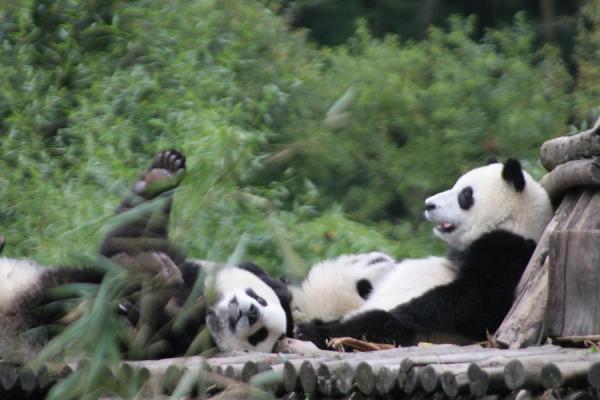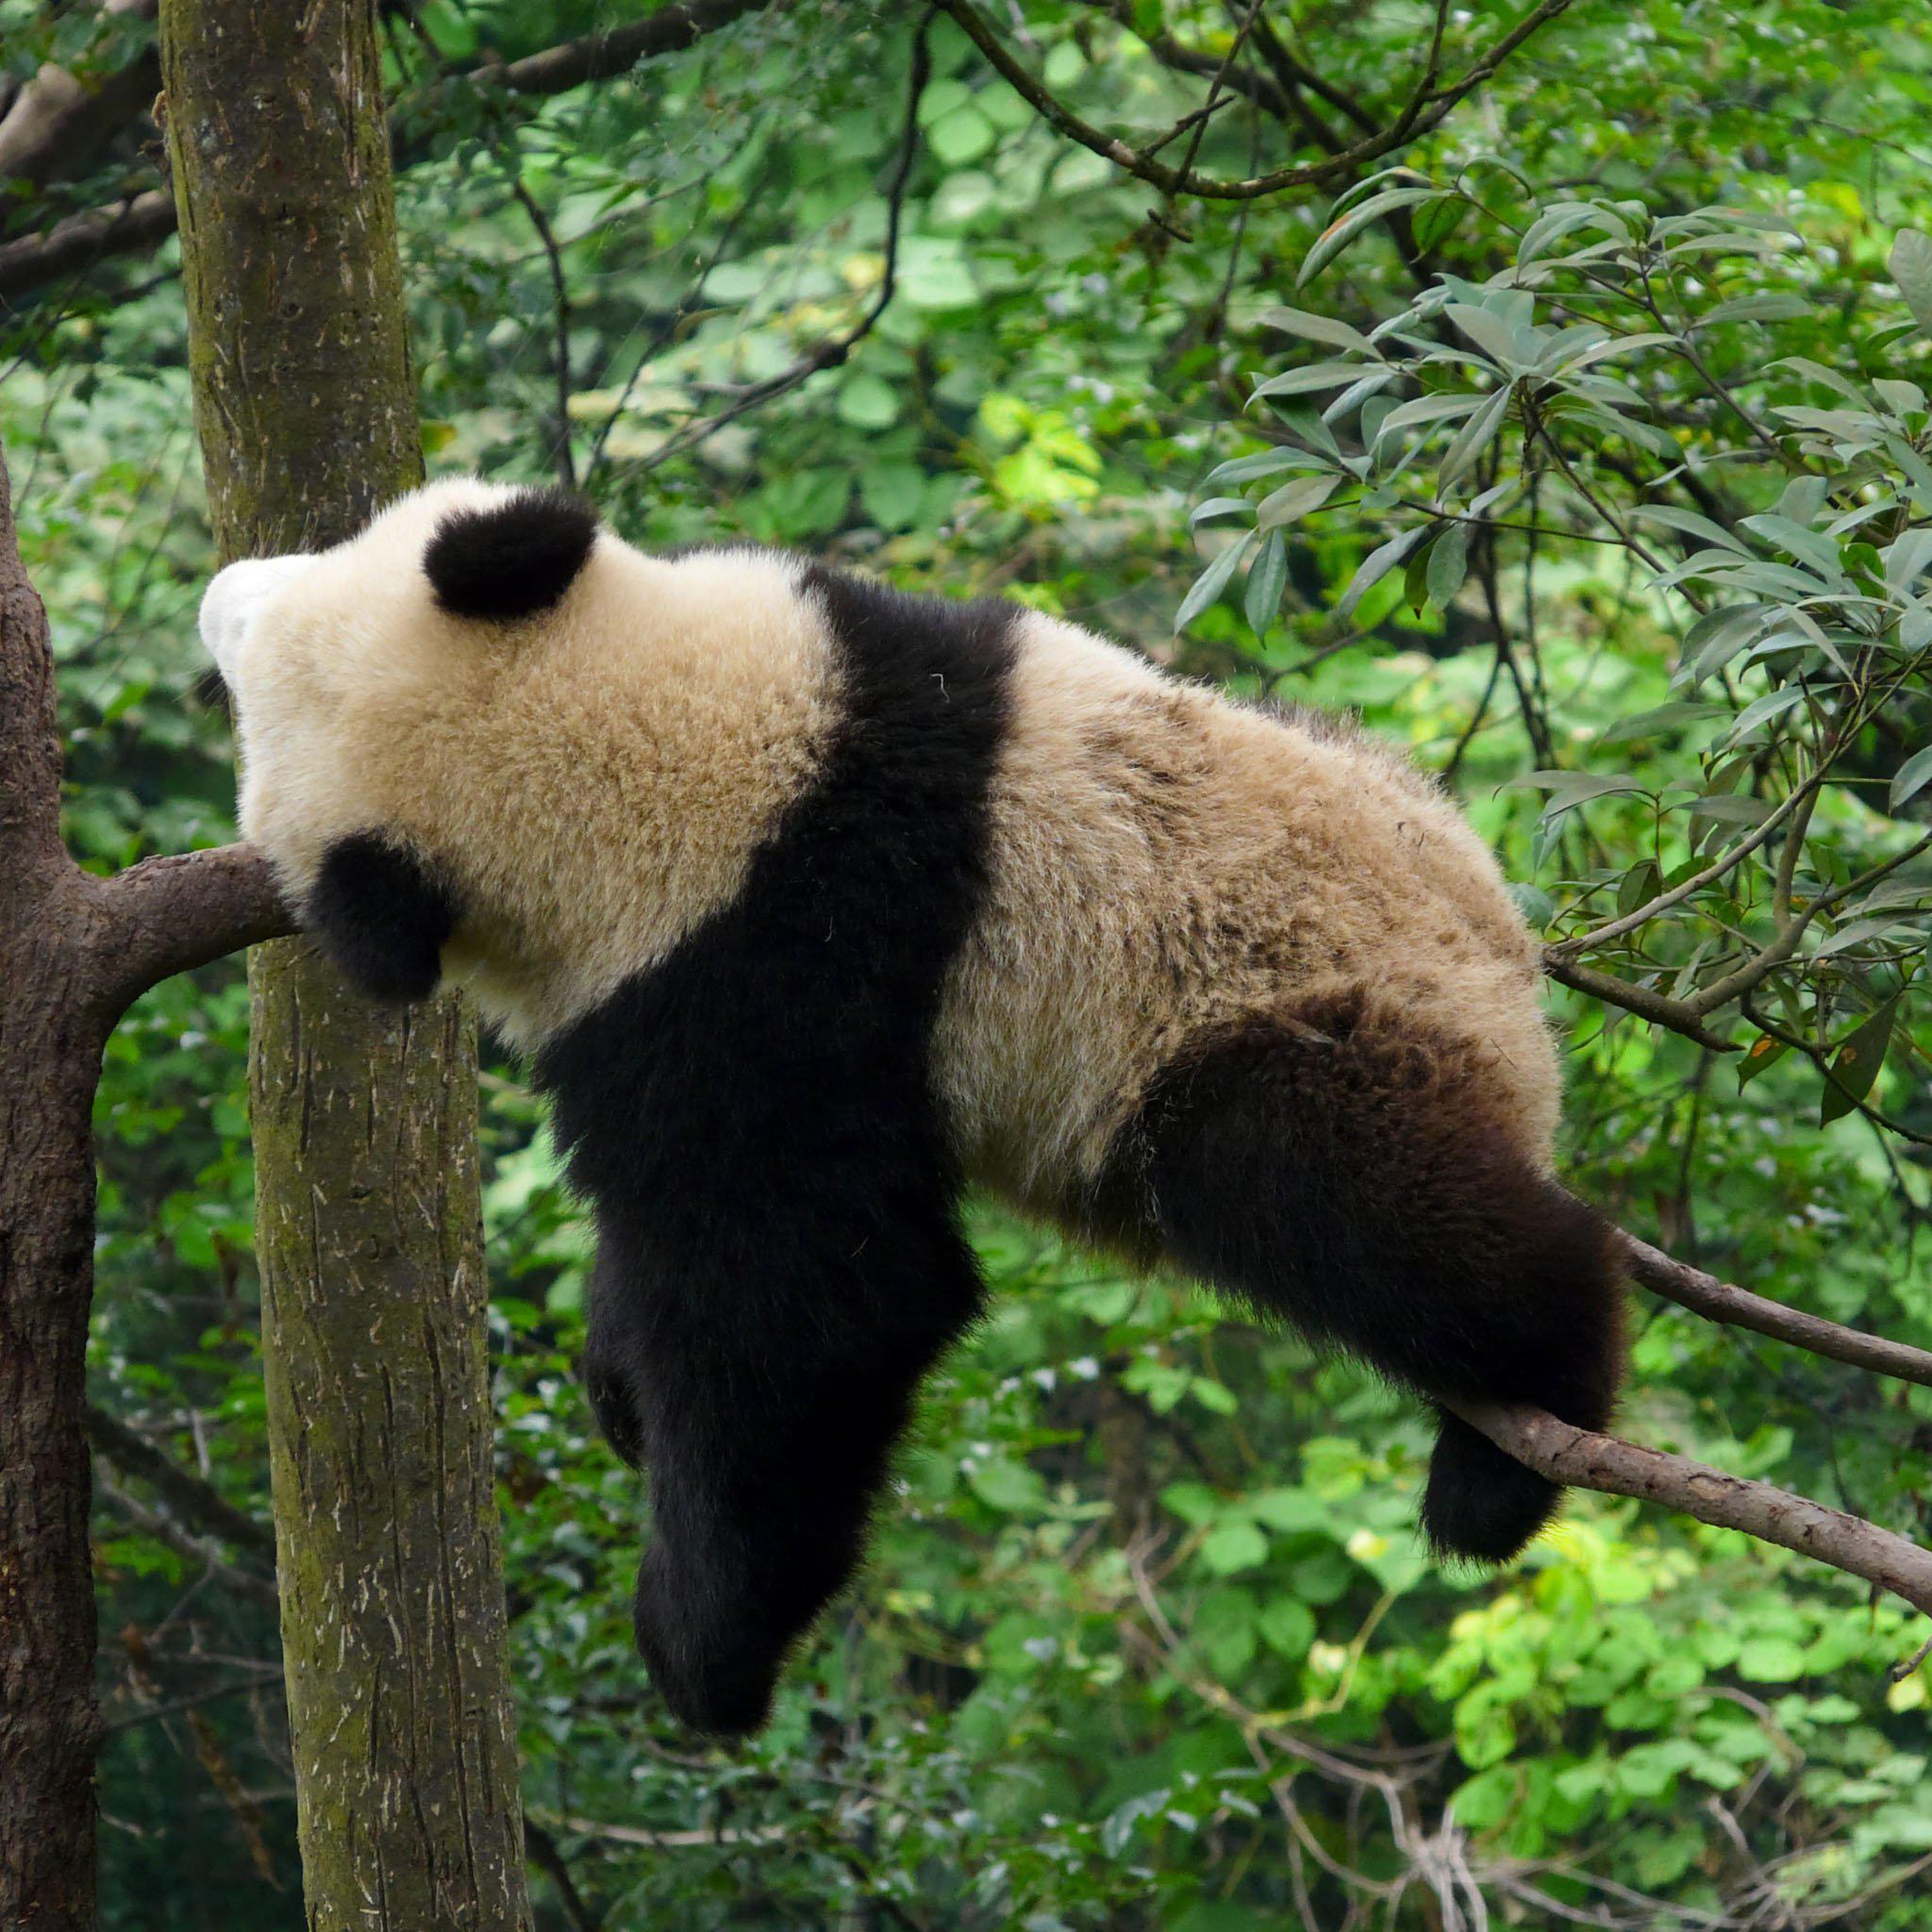The first image is the image on the left, the second image is the image on the right. Given the left and right images, does the statement "There is a panda lounging against a brown tree in one of the images." hold true? Answer yes or no. Yes. The first image is the image on the left, the second image is the image on the right. Assess this claim about the two images: "a panda is laying belly down on a tree limb". Correct or not? Answer yes or no. Yes. 